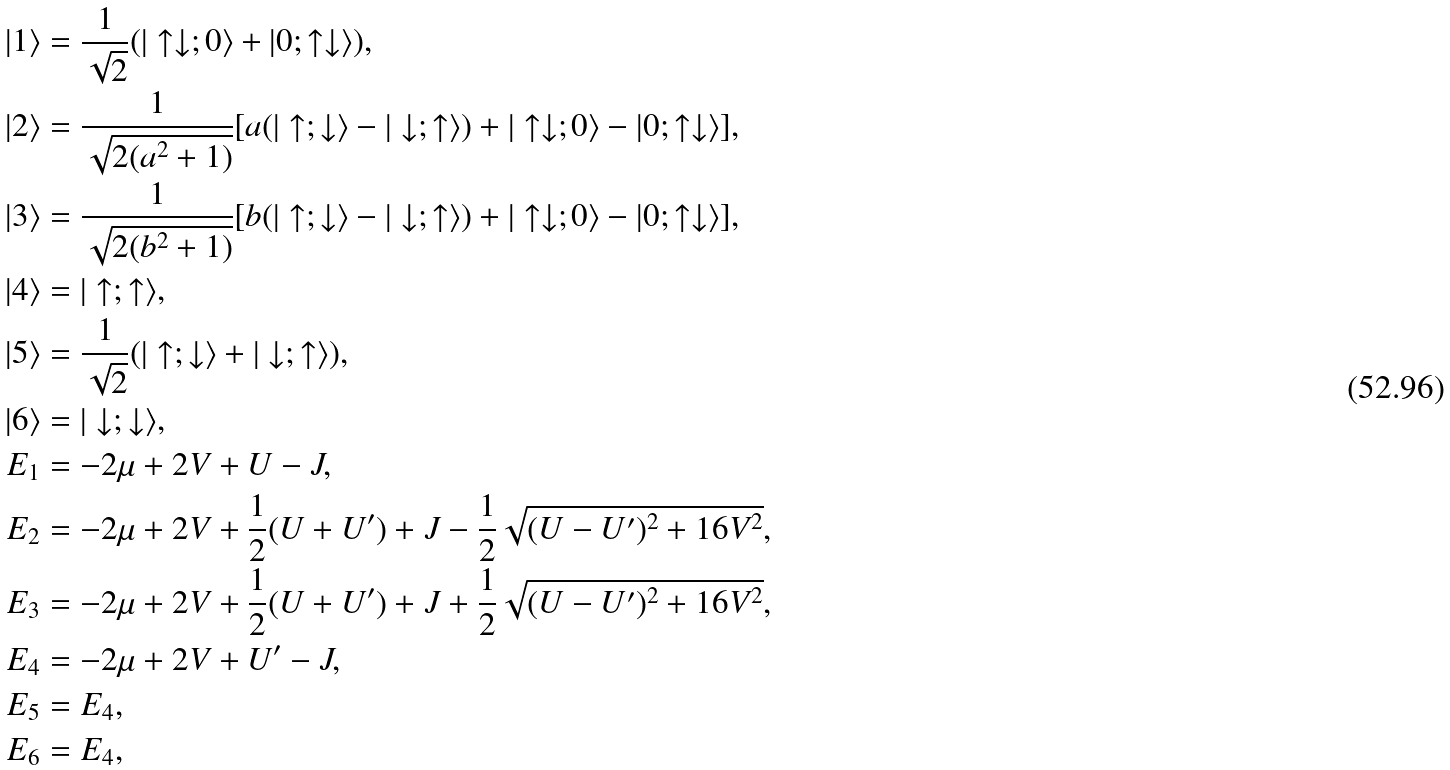Convert formula to latex. <formula><loc_0><loc_0><loc_500><loc_500>| 1 \rangle & = \frac { 1 } { \sqrt { 2 } } ( | \uparrow \downarrow ; 0 \rangle + | 0 ; \uparrow \downarrow \rangle ) , \\ | 2 \rangle & = \frac { 1 } { \sqrt { 2 ( a ^ { 2 } + 1 ) } } [ a ( | \uparrow ; \downarrow \rangle - | \downarrow ; \uparrow \rangle ) + | \uparrow \downarrow ; 0 \rangle - | 0 ; \uparrow \downarrow \rangle ] , \\ | 3 \rangle & = \frac { 1 } { \sqrt { 2 ( b ^ { 2 } + 1 ) } } [ b ( | \uparrow ; \downarrow \rangle - | \downarrow ; \uparrow \rangle ) + | \uparrow \downarrow ; 0 \rangle - | 0 ; \uparrow \downarrow \rangle ] , \\ | 4 \rangle & = | \uparrow ; \uparrow \rangle , \\ | 5 \rangle & = \frac { 1 } { \sqrt { 2 } } ( | \uparrow ; \downarrow \rangle + | \downarrow ; \uparrow \rangle ) , \\ | 6 \rangle & = | \downarrow ; \downarrow \rangle , \\ E _ { 1 } & = - 2 \mu + 2 V + U - J , \\ E _ { 2 } & = - 2 \mu + 2 V + \frac { 1 } { 2 } ( U + U ^ { \prime } ) + J - \frac { 1 } { 2 } \sqrt { ( U - U ^ { \prime } ) ^ { 2 } + 1 6 V ^ { 2 } } , \\ E _ { 3 } & = - 2 \mu + 2 V + \frac { 1 } { 2 } ( U + U ^ { \prime } ) + J + \frac { 1 } { 2 } \sqrt { ( U - U ^ { \prime } ) ^ { 2 } + 1 6 V ^ { 2 } } , \\ E _ { 4 } & = - 2 \mu + 2 V + U ^ { \prime } - J , \\ E _ { 5 } & = E _ { 4 } , \\ E _ { 6 } & = E _ { 4 } ,</formula> 